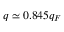Convert formula to latex. <formula><loc_0><loc_0><loc_500><loc_500>q \simeq 0 . 8 4 5 q _ { F }</formula> 